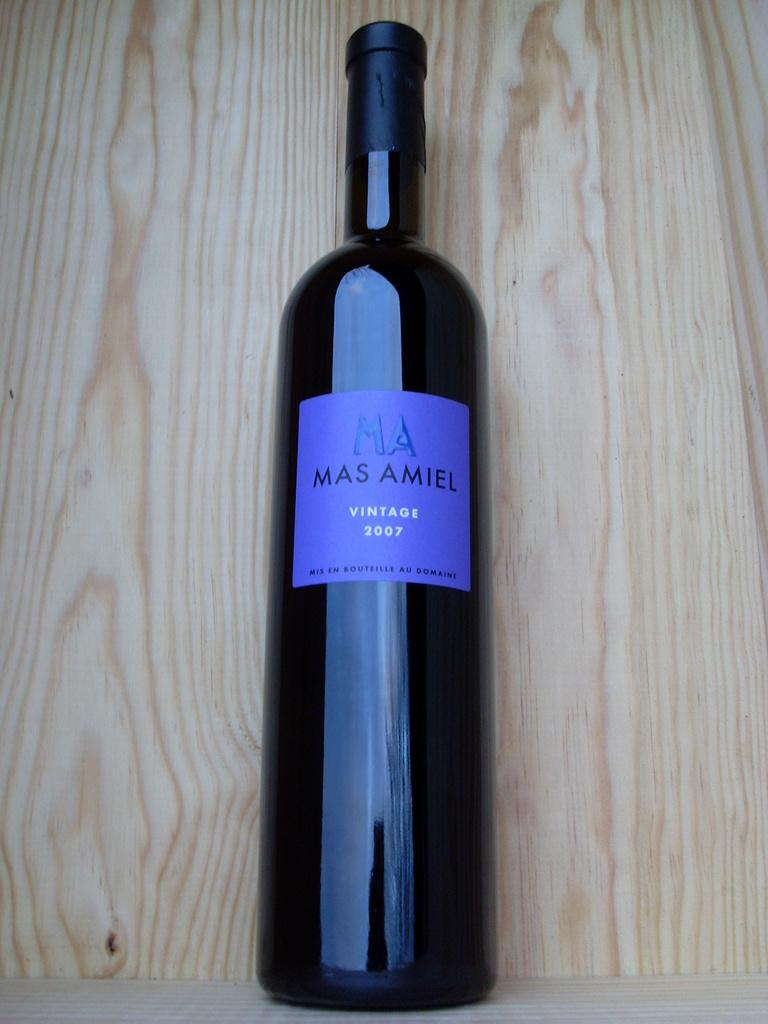<image>
Provide a brief description of the given image. A vintage 2007 bottle of Mas Amiel is laying on a piece of wood. 